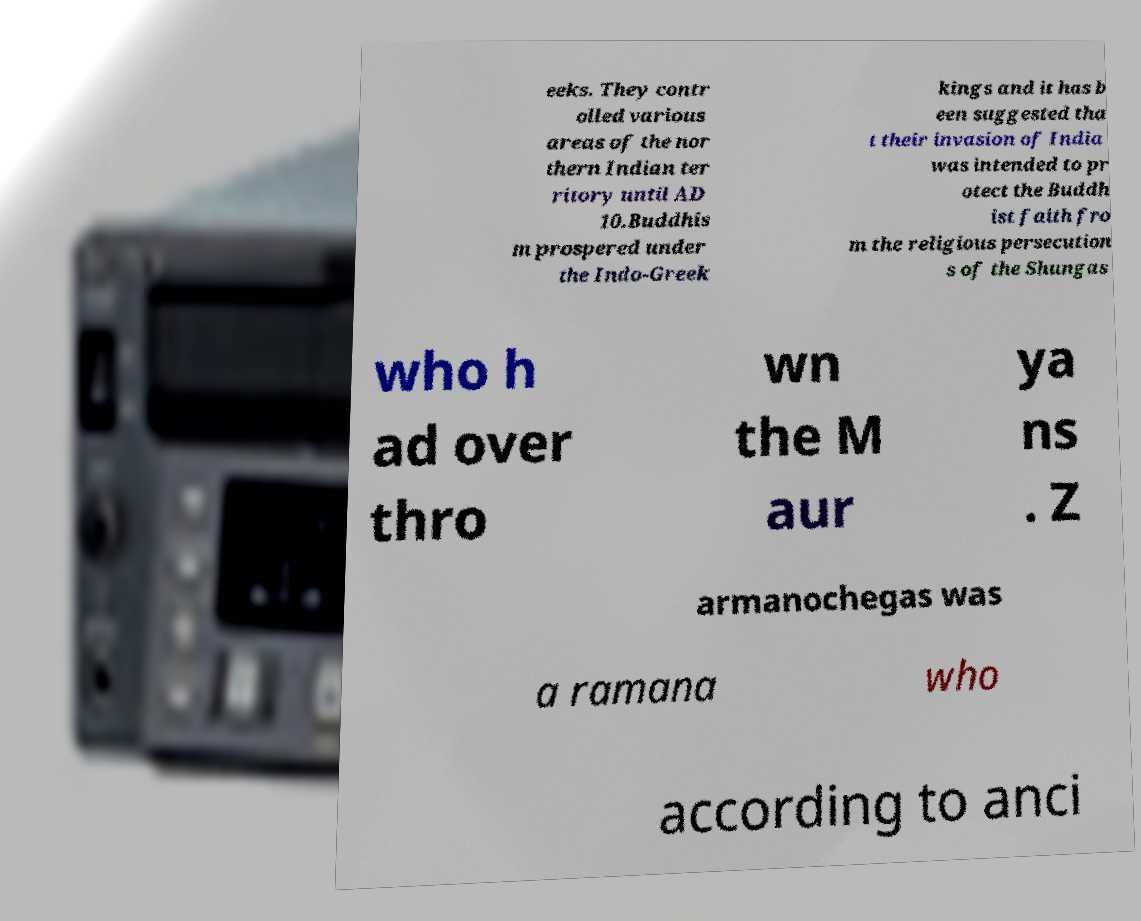For documentation purposes, I need the text within this image transcribed. Could you provide that? eeks. They contr olled various areas of the nor thern Indian ter ritory until AD 10.Buddhis m prospered under the Indo-Greek kings and it has b een suggested tha t their invasion of India was intended to pr otect the Buddh ist faith fro m the religious persecution s of the Shungas who h ad over thro wn the M aur ya ns . Z armanochegas was a ramana who according to anci 